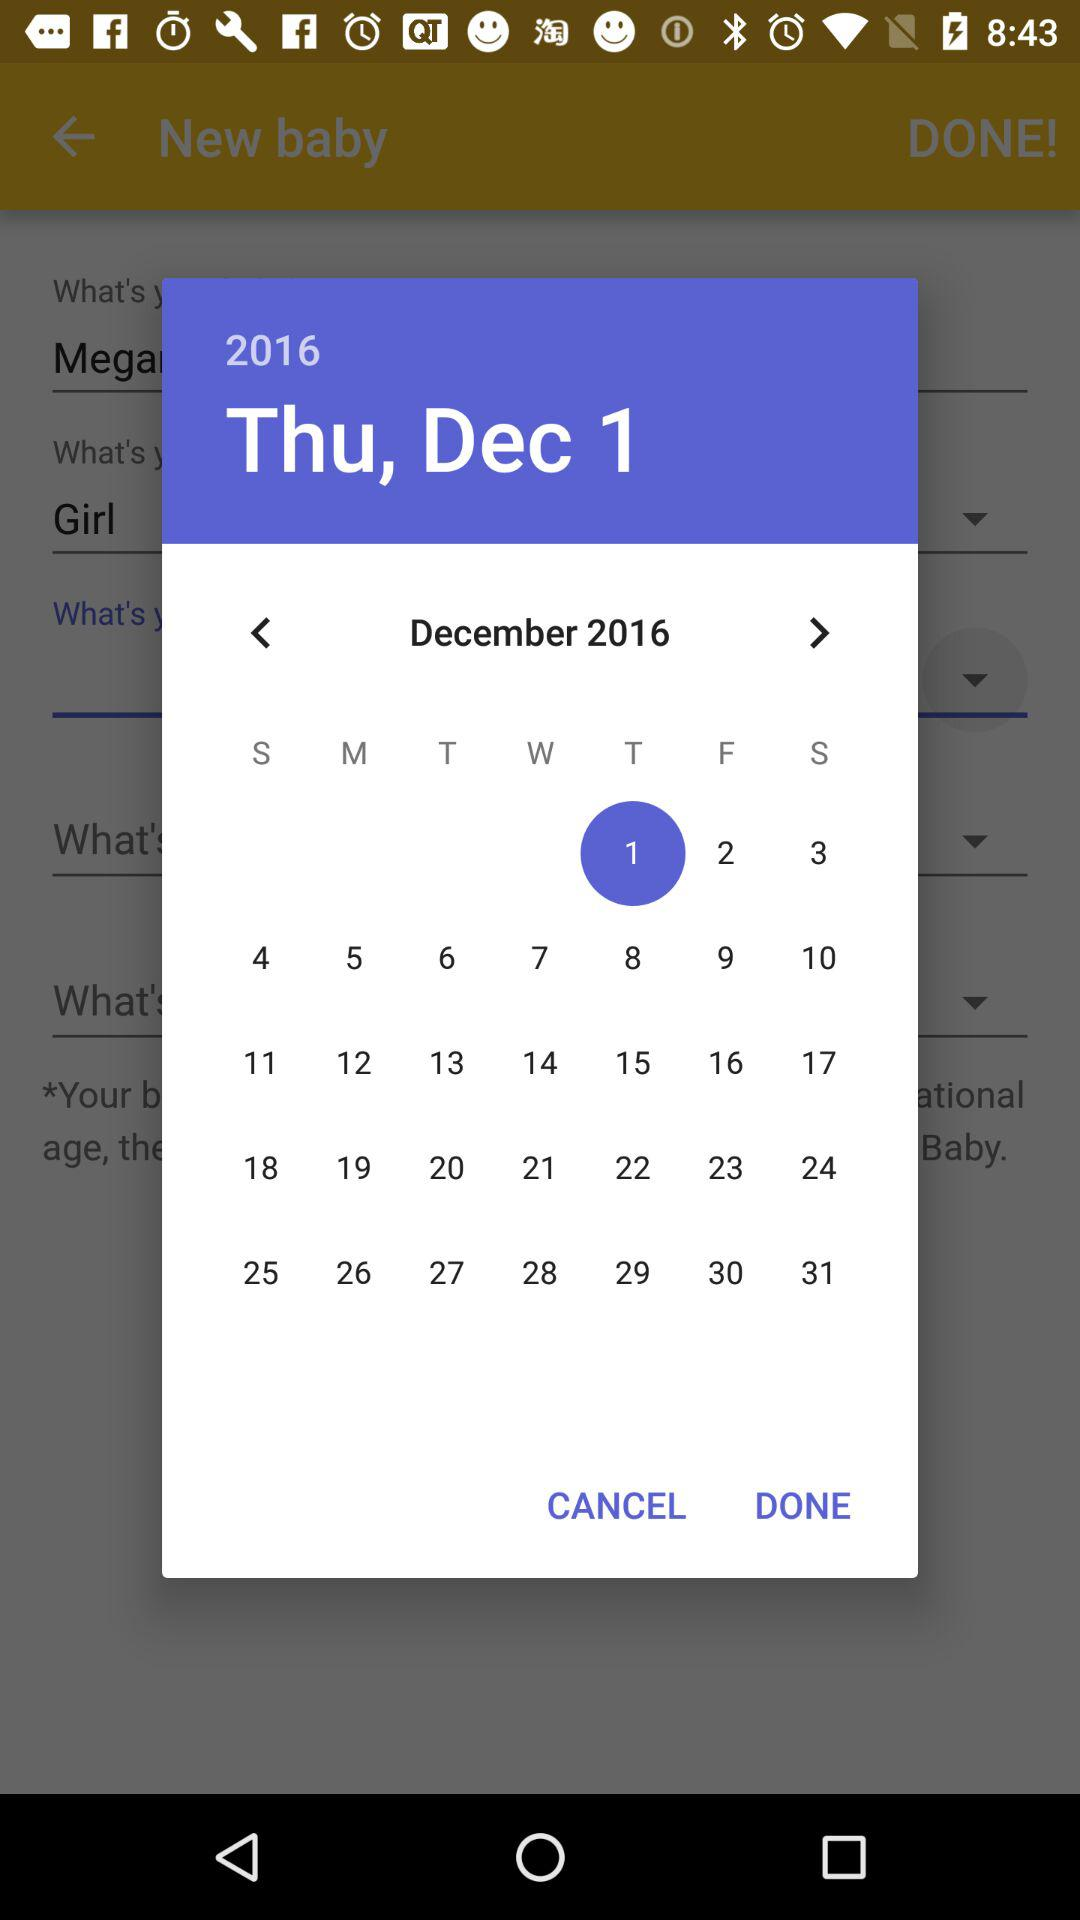Which day falls on the 15th of December 2016? The day is Thursday. 